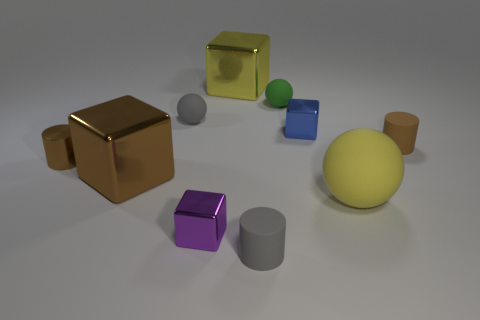How many small things are either purple metal spheres or gray things?
Offer a terse response. 2. What is the shape of the yellow shiny thing?
Give a very brief answer. Cube. What is the size of the other cylinder that is the same color as the small shiny cylinder?
Give a very brief answer. Small. Is there a small red block that has the same material as the small gray sphere?
Give a very brief answer. No. Are there more tiny matte spheres than matte objects?
Provide a succinct answer. No. Is the material of the small blue object the same as the large yellow cube?
Keep it short and to the point. Yes. What number of metal things are tiny gray cylinders or yellow cubes?
Your answer should be very brief. 1. What is the color of the other block that is the same size as the purple cube?
Your response must be concise. Blue. What number of other objects are the same shape as the tiny brown metallic thing?
Keep it short and to the point. 2. What number of cylinders are small matte objects or tiny purple metallic things?
Your answer should be very brief. 2. 